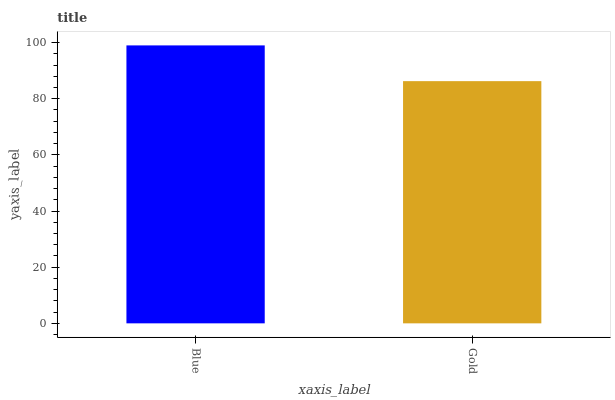Is Gold the minimum?
Answer yes or no. Yes. Is Blue the maximum?
Answer yes or no. Yes. Is Gold the maximum?
Answer yes or no. No. Is Blue greater than Gold?
Answer yes or no. Yes. Is Gold less than Blue?
Answer yes or no. Yes. Is Gold greater than Blue?
Answer yes or no. No. Is Blue less than Gold?
Answer yes or no. No. Is Blue the high median?
Answer yes or no. Yes. Is Gold the low median?
Answer yes or no. Yes. Is Gold the high median?
Answer yes or no. No. Is Blue the low median?
Answer yes or no. No. 